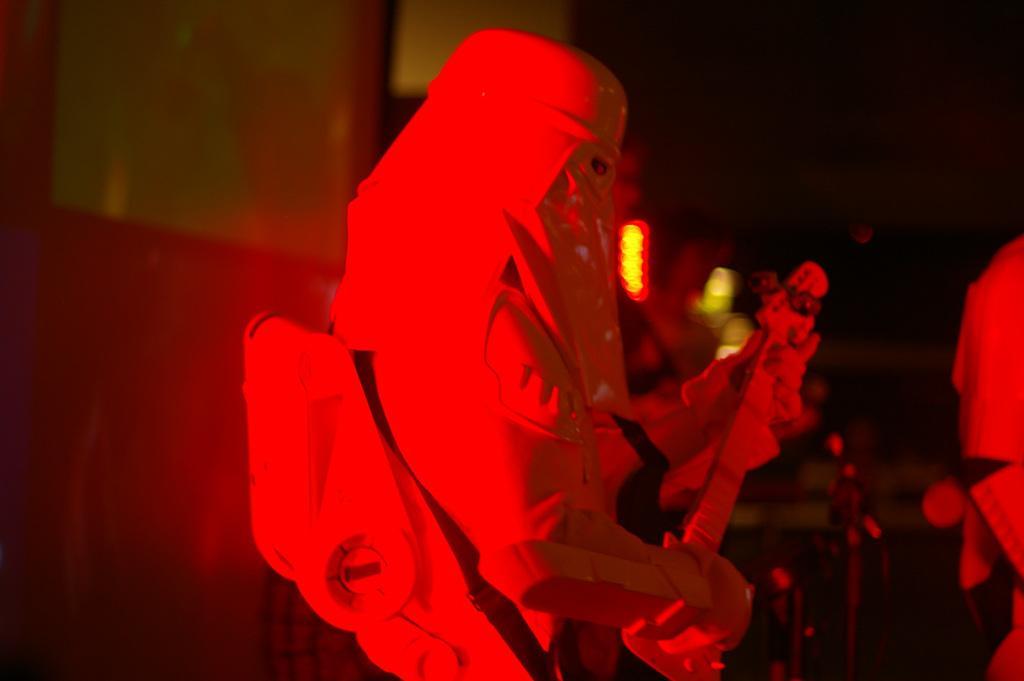In one or two sentences, can you explain what this image depicts? In this picture there is a man wearing white color full dress and playing a guitar on the stage. Behind there is a blur background. 